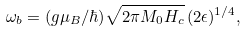Convert formula to latex. <formula><loc_0><loc_0><loc_500><loc_500>\omega _ { b } = ( g \mu _ { B } / \hbar { ) } \sqrt { 2 \pi M _ { 0 } H _ { c } } \, ( 2 \epsilon ) ^ { 1 / 4 } ,</formula> 